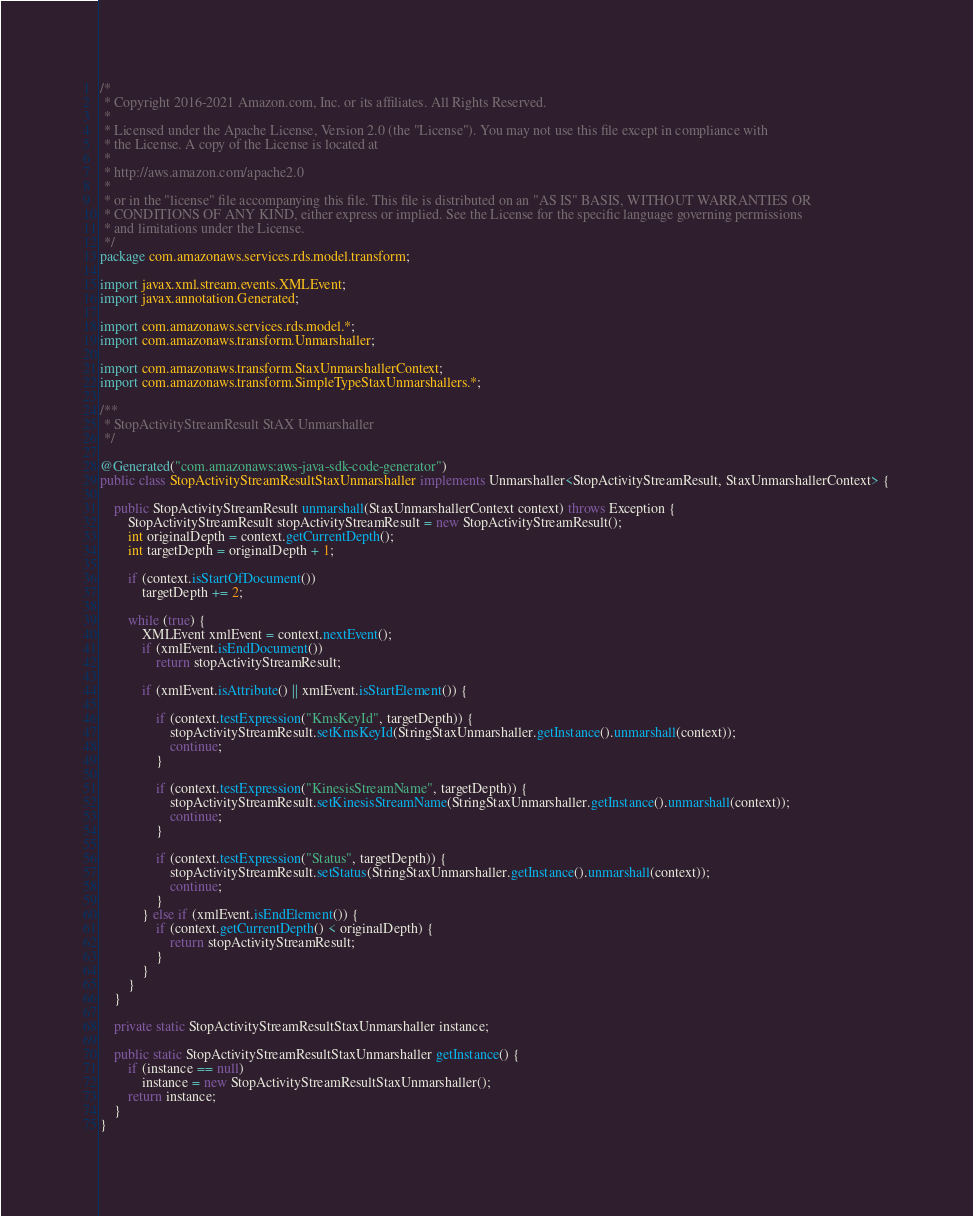Convert code to text. <code><loc_0><loc_0><loc_500><loc_500><_Java_>/*
 * Copyright 2016-2021 Amazon.com, Inc. or its affiliates. All Rights Reserved.
 * 
 * Licensed under the Apache License, Version 2.0 (the "License"). You may not use this file except in compliance with
 * the License. A copy of the License is located at
 * 
 * http://aws.amazon.com/apache2.0
 * 
 * or in the "license" file accompanying this file. This file is distributed on an "AS IS" BASIS, WITHOUT WARRANTIES OR
 * CONDITIONS OF ANY KIND, either express or implied. See the License for the specific language governing permissions
 * and limitations under the License.
 */
package com.amazonaws.services.rds.model.transform;

import javax.xml.stream.events.XMLEvent;
import javax.annotation.Generated;

import com.amazonaws.services.rds.model.*;
import com.amazonaws.transform.Unmarshaller;

import com.amazonaws.transform.StaxUnmarshallerContext;
import com.amazonaws.transform.SimpleTypeStaxUnmarshallers.*;

/**
 * StopActivityStreamResult StAX Unmarshaller
 */

@Generated("com.amazonaws:aws-java-sdk-code-generator")
public class StopActivityStreamResultStaxUnmarshaller implements Unmarshaller<StopActivityStreamResult, StaxUnmarshallerContext> {

    public StopActivityStreamResult unmarshall(StaxUnmarshallerContext context) throws Exception {
        StopActivityStreamResult stopActivityStreamResult = new StopActivityStreamResult();
        int originalDepth = context.getCurrentDepth();
        int targetDepth = originalDepth + 1;

        if (context.isStartOfDocument())
            targetDepth += 2;

        while (true) {
            XMLEvent xmlEvent = context.nextEvent();
            if (xmlEvent.isEndDocument())
                return stopActivityStreamResult;

            if (xmlEvent.isAttribute() || xmlEvent.isStartElement()) {

                if (context.testExpression("KmsKeyId", targetDepth)) {
                    stopActivityStreamResult.setKmsKeyId(StringStaxUnmarshaller.getInstance().unmarshall(context));
                    continue;
                }

                if (context.testExpression("KinesisStreamName", targetDepth)) {
                    stopActivityStreamResult.setKinesisStreamName(StringStaxUnmarshaller.getInstance().unmarshall(context));
                    continue;
                }

                if (context.testExpression("Status", targetDepth)) {
                    stopActivityStreamResult.setStatus(StringStaxUnmarshaller.getInstance().unmarshall(context));
                    continue;
                }
            } else if (xmlEvent.isEndElement()) {
                if (context.getCurrentDepth() < originalDepth) {
                    return stopActivityStreamResult;
                }
            }
        }
    }

    private static StopActivityStreamResultStaxUnmarshaller instance;

    public static StopActivityStreamResultStaxUnmarshaller getInstance() {
        if (instance == null)
            instance = new StopActivityStreamResultStaxUnmarshaller();
        return instance;
    }
}
</code> 